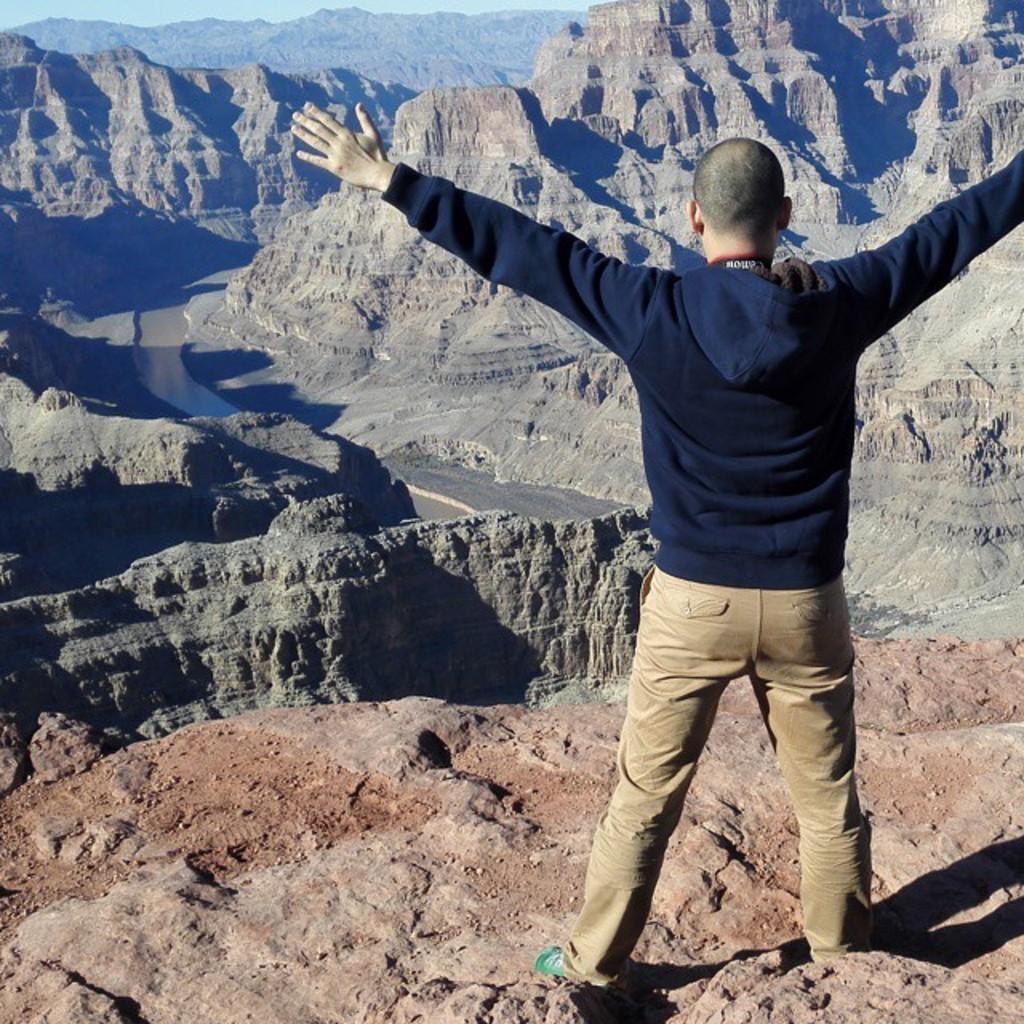Describe this image in one or two sentences. In this image we can see the one person stretching his hands standing on upper side of the hill. And the surrounding places is covered by stony hill. And we can see sky with clouds. 